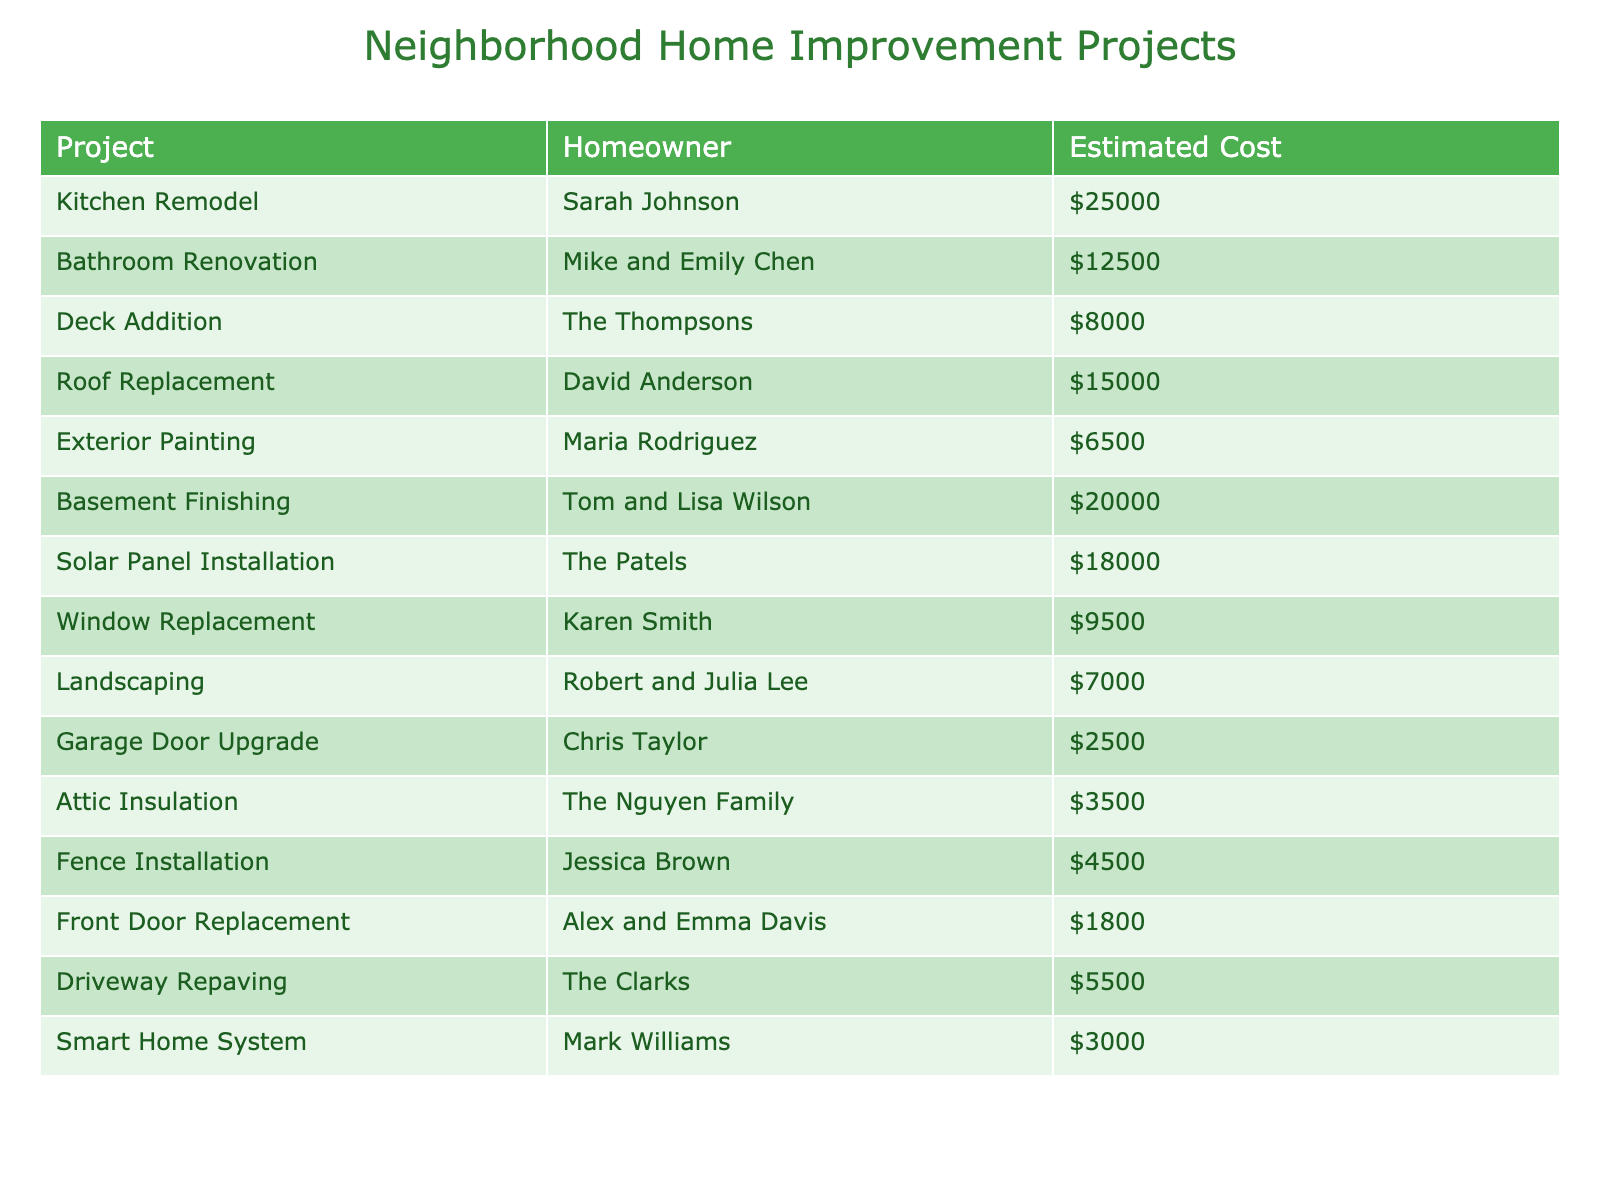What is the estimated cost of the kitchen remodel? The table lists the estimated cost for each project. The kitchen remodel, which is assigned to Sarah Johnson, shows an estimated cost of $25,000.
Answer: $25,000 How many projects have an estimated cost more than $10,000? To answer this, we can count the projects for which the estimated cost exceeds $10,000. The projects that fit this criterion are the kitchen remodel, bathroom renovation, basement finishing, solar panel installation, roof replacement, and deck addition. There are 6 such projects.
Answer: 6 Which project has the lowest estimated cost? Referring to the estimated costs in the table, the project with the lowest estimated cost is the front door replacement at $1,800.
Answer: $1,800 Is there any project that costs exactly $5,500? Looking through the table, the estimated costs listed do not include any project priced exactly at $5,500. Thus, the statement is false.
Answer: No What is the total estimated cost of all the home improvement projects? To find this, we can sum up all the estimated costs. The calculations are: $25,000 + $12,500 + $8,000 + $15,000 + $6,500 + $20,000 + $18,000 + $9,500 + $7,000 + $2,500 + $3,500 + $4,500 + $1,800 + $5,500 + $3,000 = $182,300.
Answer: $182,300 Which homeowners have projects that cost over $15,000? Reviewing the table, the homeowners with projects exceeding $15,000 are Sarah Johnson, Tom and Lisa Wilson, David Anderson, and The Patels. Thus, there are 4 homeowners in total.
Answer: 4 What is the average estimated cost of all projects listed in the table? We first found the total estimated cost as $182,300, and since there are 15 projects, we divide the total by the number of projects: $182,300 / 15 = $12,153.33. Therefore, the average estimated cost is approximately $12,153.33.
Answer: $12,153.33 How much more does the solar panel installation cost compared to the garage door upgrade? The estimated costs are $18,000 for the solar panel installation and $2,500 for the garage door upgrade. The difference is $18,000 - $2,500 = $15,500.
Answer: $15,500 Are there more projects over $10,000 or projects under $10,000? There are 6 projects over $10,000 and 9 projects under $10,000. Since 9 is greater than 6, there are more projects categorized under $10,000.
Answer: More under $10,000 What is the total estimated cost of projects that involve outdoor improvements (like deck addition, landscaping, and fence installation)? The costs for outdoor improvements are $8,000 (deck addition) + $7,000 (landscaping) + $4,500 (fence installation) = $19,500.
Answer: $19,500 Which project has a higher estimated cost: bathroom renovation or window replacement? The bathroom renovation costs $12,500 while the window replacement costs $9,500. Since $12,500 is greater than $9,500, bathroom renovation has a higher cost.
Answer: Bathroom renovation 